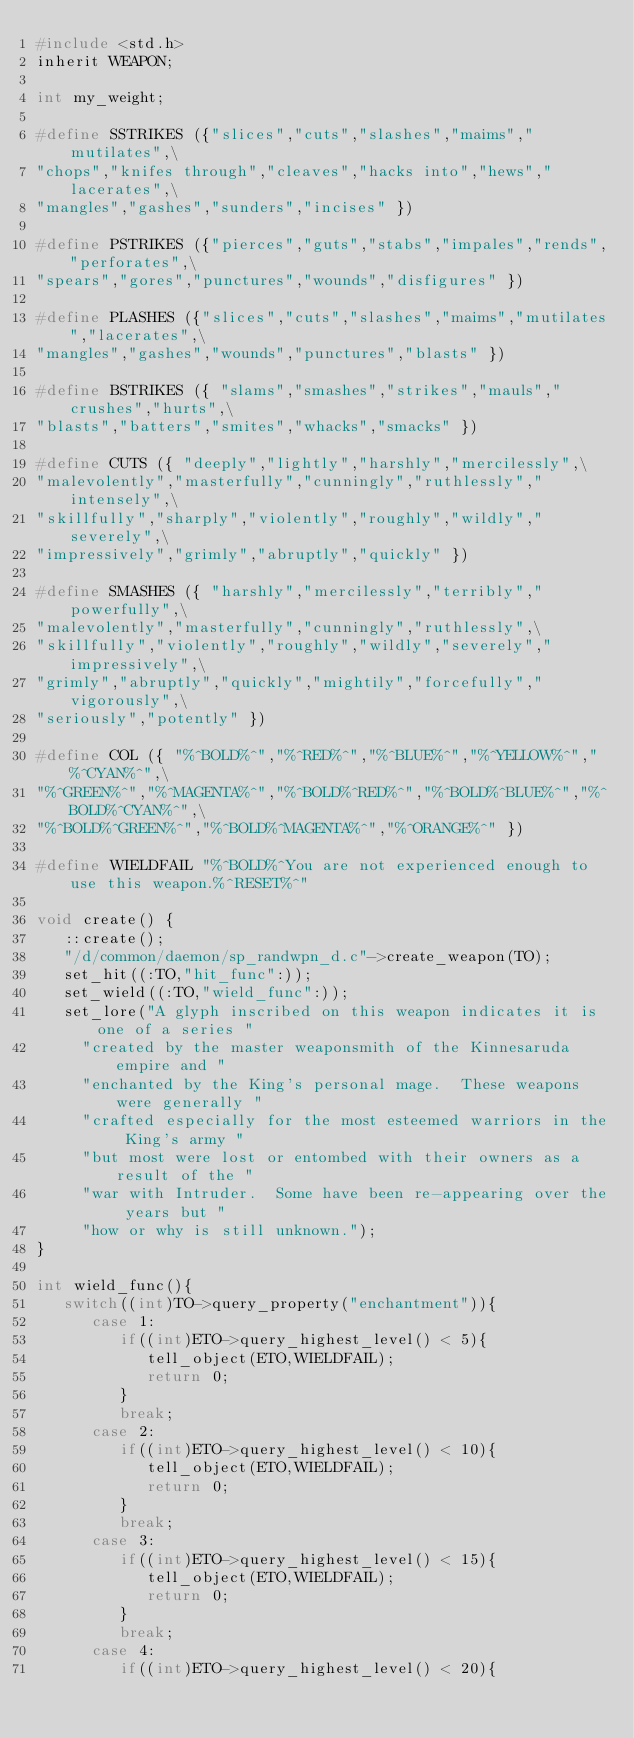Convert code to text. <code><loc_0><loc_0><loc_500><loc_500><_C_>#include <std.h>
inherit WEAPON;

int my_weight;

#define SSTRIKES ({"slices","cuts","slashes","maims","mutilates",\
"chops","knifes through","cleaves","hacks into","hews","lacerates",\
"mangles","gashes","sunders","incises" })

#define PSTRIKES ({"pierces","guts","stabs","impales","rends","perforates",\
"spears","gores","punctures","wounds","disfigures" })

#define PLASHES ({"slices","cuts","slashes","maims","mutilates","lacerates",\
"mangles","gashes","wounds","punctures","blasts" })

#define BSTRIKES ({ "slams","smashes","strikes","mauls","crushes","hurts",\
"blasts","batters","smites","whacks","smacks" })

#define CUTS ({	"deeply","lightly","harshly","mercilessly",\
"malevolently","masterfully","cunningly","ruthlessly","intensely",\
"skillfully","sharply","violently","roughly","wildly","severely",\
"impressively","grimly","abruptly","quickly" })

#define SMASHES ({ "harshly","mercilessly","terribly","powerfully",\
"malevolently","masterfully","cunningly","ruthlessly",\
"skillfully","violently","roughly","wildly","severely","impressively",\
"grimly","abruptly","quickly","mightily","forcefully","vigorously",\
"seriously","potently" })

#define COL ({ "%^BOLD%^","%^RED%^","%^BLUE%^","%^YELLOW%^","%^CYAN%^",\
"%^GREEN%^","%^MAGENTA%^","%^BOLD%^RED%^","%^BOLD%^BLUE%^","%^BOLD%^CYAN%^",\
"%^BOLD%^GREEN%^","%^BOLD%^MAGENTA%^","%^ORANGE%^" })

#define WIELDFAIL "%^BOLD%^You are not experienced enough to use this weapon.%^RESET%^"

void create() {
   ::create();
   "/d/common/daemon/sp_randwpn_d.c"->create_weapon(TO);
   set_hit((:TO,"hit_func":));
   set_wield((:TO,"wield_func":));
   set_lore("A glyph inscribed on this weapon indicates it is one of a series "
     "created by the master weaponsmith of the Kinnesaruda empire and "
     "enchanted by the King's personal mage.  These weapons were generally "
     "crafted especially for the most esteemed warriors in the King's army "
     "but most were lost or entombed with their owners as a result of the "
     "war with Intruder.  Some have been re-appearing over the years but "
     "how or why is still unknown.");
}

int wield_func(){
   switch((int)TO->query_property("enchantment")){
      case 1:
         if((int)ETO->query_highest_level() < 5){
            tell_object(ETO,WIELDFAIL);
            return 0;
         }
         break;
      case 2:
         if((int)ETO->query_highest_level() < 10){
            tell_object(ETO,WIELDFAIL);
            return 0;
         }
         break;
      case 3:
         if((int)ETO->query_highest_level() < 15){
            tell_object(ETO,WIELDFAIL);
            return 0;
         }
         break;
      case 4:
         if((int)ETO->query_highest_level() < 20){</code> 